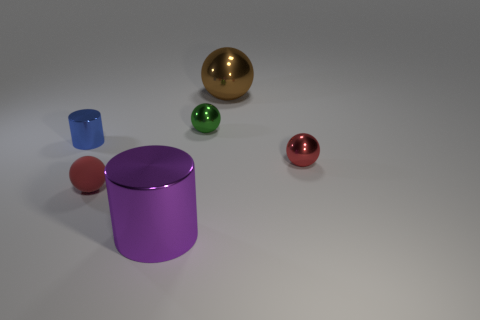How many green things are in front of the tiny blue thing?
Provide a succinct answer. 0. What size is the purple metallic cylinder?
Give a very brief answer. Large. Is the tiny red ball that is behind the rubber sphere made of the same material as the large thing on the left side of the brown ball?
Provide a short and direct response. Yes. Are there any large metallic cylinders of the same color as the matte ball?
Provide a short and direct response. No. The other rubber thing that is the same size as the blue thing is what color?
Your response must be concise. Red. Is the color of the sphere that is to the right of the large ball the same as the large metallic sphere?
Offer a very short reply. No. Are there any small green balls made of the same material as the large ball?
Keep it short and to the point. Yes. What shape is the thing that is the same color as the tiny rubber sphere?
Offer a terse response. Sphere. Is the number of cylinders that are behind the brown sphere less than the number of large blue matte things?
Offer a very short reply. No. Is the size of the shiny cylinder to the right of the blue cylinder the same as the blue metal thing?
Make the answer very short. No. 